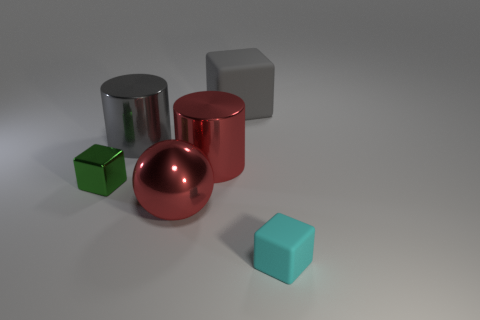There is a tiny object on the right side of the large metallic thing in front of the small cube that is on the left side of the big gray rubber thing; what is its color?
Your response must be concise. Cyan. Do the green shiny object and the rubber thing in front of the tiny green shiny block have the same shape?
Ensure brevity in your answer.  Yes. What color is the object that is both left of the big gray matte cube and in front of the tiny green block?
Offer a very short reply. Red. Is there another small object that has the same shape as the green thing?
Give a very brief answer. Yes. Is there a small object to the right of the big red object in front of the green metallic thing?
Make the answer very short. Yes. How many things are either cubes that are to the right of the large red cylinder or rubber things that are behind the green shiny object?
Your answer should be compact. 2. What number of objects are either metallic cylinders or things that are behind the big metallic ball?
Offer a very short reply. 4. What is the size of the shiny thing in front of the small cube behind the matte cube that is in front of the big gray cube?
Give a very brief answer. Large. What material is the other object that is the same size as the cyan rubber thing?
Offer a terse response. Metal. Are there any rubber things of the same size as the red metal cylinder?
Give a very brief answer. Yes. 